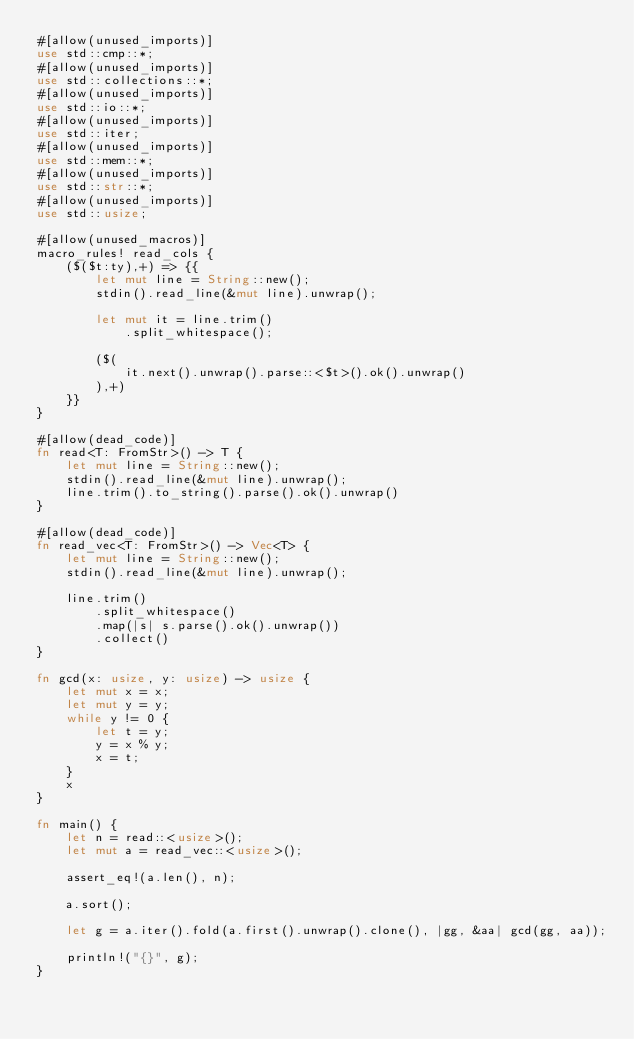<code> <loc_0><loc_0><loc_500><loc_500><_Rust_>#[allow(unused_imports)]
use std::cmp::*;
#[allow(unused_imports)]
use std::collections::*;
#[allow(unused_imports)]
use std::io::*;
#[allow(unused_imports)]
use std::iter;
#[allow(unused_imports)]
use std::mem::*;
#[allow(unused_imports)]
use std::str::*;
#[allow(unused_imports)]
use std::usize;

#[allow(unused_macros)]
macro_rules! read_cols {
    ($($t:ty),+) => {{
        let mut line = String::new();
        stdin().read_line(&mut line).unwrap();

        let mut it = line.trim()
            .split_whitespace();

        ($(
            it.next().unwrap().parse::<$t>().ok().unwrap()
        ),+)
    }}
}

#[allow(dead_code)]
fn read<T: FromStr>() -> T {
    let mut line = String::new();
    stdin().read_line(&mut line).unwrap();
    line.trim().to_string().parse().ok().unwrap()
}

#[allow(dead_code)]
fn read_vec<T: FromStr>() -> Vec<T> {
    let mut line = String::new();
    stdin().read_line(&mut line).unwrap();

    line.trim()
        .split_whitespace()
        .map(|s| s.parse().ok().unwrap())
        .collect()
}

fn gcd(x: usize, y: usize) -> usize {
    let mut x = x;
    let mut y = y;
    while y != 0 {
        let t = y;
        y = x % y;
        x = t;
    }
    x
}

fn main() {
    let n = read::<usize>();
    let mut a = read_vec::<usize>();

    assert_eq!(a.len(), n);

    a.sort();

    let g = a.iter().fold(a.first().unwrap().clone(), |gg, &aa| gcd(gg, aa));

    println!("{}", g);
}
</code> 